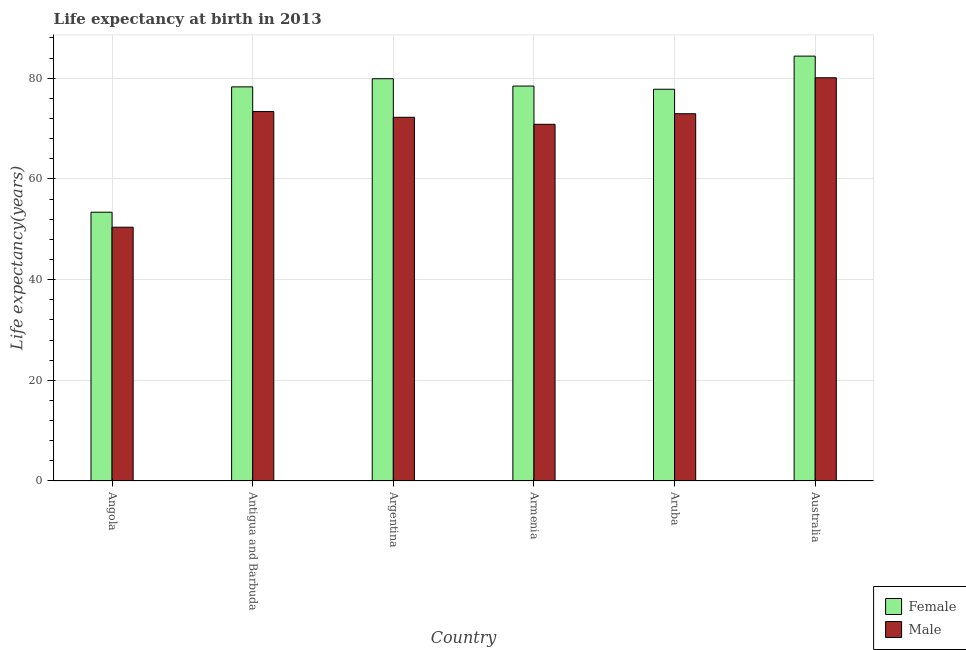How many groups of bars are there?
Offer a terse response. 6. Are the number of bars per tick equal to the number of legend labels?
Offer a terse response. Yes. How many bars are there on the 6th tick from the left?
Provide a succinct answer. 2. What is the label of the 4th group of bars from the left?
Your response must be concise. Armenia. In how many cases, is the number of bars for a given country not equal to the number of legend labels?
Provide a succinct answer. 0. What is the life expectancy(female) in Aruba?
Offer a terse response. 77.82. Across all countries, what is the maximum life expectancy(male)?
Your answer should be very brief. 80.1. Across all countries, what is the minimum life expectancy(male)?
Offer a very short reply. 50.41. In which country was the life expectancy(female) maximum?
Your answer should be very brief. Australia. In which country was the life expectancy(female) minimum?
Your answer should be compact. Angola. What is the total life expectancy(female) in the graph?
Your answer should be compact. 452.27. What is the difference between the life expectancy(male) in Antigua and Barbuda and that in Armenia?
Your answer should be very brief. 2.53. What is the difference between the life expectancy(male) in Australia and the life expectancy(female) in Antigua and Barbuda?
Your answer should be compact. 1.81. What is the average life expectancy(male) per country?
Provide a succinct answer. 69.99. What is the difference between the life expectancy(male) and life expectancy(female) in Aruba?
Give a very brief answer. -4.87. What is the ratio of the life expectancy(female) in Antigua and Barbuda to that in Argentina?
Provide a short and direct response. 0.98. Is the life expectancy(female) in Angola less than that in Australia?
Ensure brevity in your answer.  Yes. Is the difference between the life expectancy(male) in Antigua and Barbuda and Argentina greater than the difference between the life expectancy(female) in Antigua and Barbuda and Argentina?
Keep it short and to the point. Yes. What is the difference between the highest and the second highest life expectancy(male)?
Your answer should be very brief. 6.71. What is the difference between the highest and the lowest life expectancy(female)?
Provide a short and direct response. 31.01. In how many countries, is the life expectancy(female) greater than the average life expectancy(female) taken over all countries?
Ensure brevity in your answer.  5. What is the difference between two consecutive major ticks on the Y-axis?
Keep it short and to the point. 20. Does the graph contain grids?
Provide a short and direct response. Yes. How are the legend labels stacked?
Offer a very short reply. Vertical. What is the title of the graph?
Make the answer very short. Life expectancy at birth in 2013. Does "Official aid received" appear as one of the legend labels in the graph?
Make the answer very short. No. What is the label or title of the Y-axis?
Offer a very short reply. Life expectancy(years). What is the Life expectancy(years) in Female in Angola?
Give a very brief answer. 53.39. What is the Life expectancy(years) in Male in Angola?
Your answer should be compact. 50.41. What is the Life expectancy(years) of Female in Antigua and Barbuda?
Give a very brief answer. 78.29. What is the Life expectancy(years) in Male in Antigua and Barbuda?
Offer a very short reply. 73.39. What is the Life expectancy(years) in Female in Argentina?
Keep it short and to the point. 79.91. What is the Life expectancy(years) in Male in Argentina?
Offer a very short reply. 72.25. What is the Life expectancy(years) in Female in Armenia?
Your answer should be compact. 78.45. What is the Life expectancy(years) in Male in Armenia?
Provide a short and direct response. 70.86. What is the Life expectancy(years) in Female in Aruba?
Your answer should be very brief. 77.82. What is the Life expectancy(years) of Male in Aruba?
Your response must be concise. 72.95. What is the Life expectancy(years) of Female in Australia?
Offer a terse response. 84.4. What is the Life expectancy(years) of Male in Australia?
Your answer should be very brief. 80.1. Across all countries, what is the maximum Life expectancy(years) of Female?
Your answer should be compact. 84.4. Across all countries, what is the maximum Life expectancy(years) in Male?
Offer a very short reply. 80.1. Across all countries, what is the minimum Life expectancy(years) of Female?
Provide a short and direct response. 53.39. Across all countries, what is the minimum Life expectancy(years) in Male?
Your answer should be very brief. 50.41. What is the total Life expectancy(years) of Female in the graph?
Your answer should be very brief. 452.27. What is the total Life expectancy(years) of Male in the graph?
Ensure brevity in your answer.  419.96. What is the difference between the Life expectancy(years) in Female in Angola and that in Antigua and Barbuda?
Provide a short and direct response. -24.9. What is the difference between the Life expectancy(years) of Male in Angola and that in Antigua and Barbuda?
Your answer should be very brief. -22.97. What is the difference between the Life expectancy(years) of Female in Angola and that in Argentina?
Offer a very short reply. -26.52. What is the difference between the Life expectancy(years) of Male in Angola and that in Argentina?
Provide a succinct answer. -21.84. What is the difference between the Life expectancy(years) in Female in Angola and that in Armenia?
Your response must be concise. -25.06. What is the difference between the Life expectancy(years) of Male in Angola and that in Armenia?
Provide a short and direct response. -20.44. What is the difference between the Life expectancy(years) in Female in Angola and that in Aruba?
Ensure brevity in your answer.  -24.43. What is the difference between the Life expectancy(years) in Male in Angola and that in Aruba?
Offer a terse response. -22.54. What is the difference between the Life expectancy(years) in Female in Angola and that in Australia?
Make the answer very short. -31.01. What is the difference between the Life expectancy(years) in Male in Angola and that in Australia?
Give a very brief answer. -29.69. What is the difference between the Life expectancy(years) of Female in Antigua and Barbuda and that in Argentina?
Your answer should be very brief. -1.62. What is the difference between the Life expectancy(years) in Male in Antigua and Barbuda and that in Argentina?
Provide a succinct answer. 1.14. What is the difference between the Life expectancy(years) of Female in Antigua and Barbuda and that in Armenia?
Your answer should be very brief. -0.16. What is the difference between the Life expectancy(years) in Male in Antigua and Barbuda and that in Armenia?
Make the answer very short. 2.53. What is the difference between the Life expectancy(years) in Female in Antigua and Barbuda and that in Aruba?
Your response must be concise. 0.47. What is the difference between the Life expectancy(years) in Male in Antigua and Barbuda and that in Aruba?
Offer a very short reply. 0.43. What is the difference between the Life expectancy(years) in Female in Antigua and Barbuda and that in Australia?
Make the answer very short. -6.11. What is the difference between the Life expectancy(years) of Male in Antigua and Barbuda and that in Australia?
Make the answer very short. -6.71. What is the difference between the Life expectancy(years) of Female in Argentina and that in Armenia?
Make the answer very short. 1.46. What is the difference between the Life expectancy(years) of Male in Argentina and that in Armenia?
Your answer should be very brief. 1.39. What is the difference between the Life expectancy(years) of Female in Argentina and that in Aruba?
Ensure brevity in your answer.  2.09. What is the difference between the Life expectancy(years) of Male in Argentina and that in Aruba?
Provide a succinct answer. -0.7. What is the difference between the Life expectancy(years) of Female in Argentina and that in Australia?
Offer a very short reply. -4.49. What is the difference between the Life expectancy(years) of Male in Argentina and that in Australia?
Keep it short and to the point. -7.85. What is the difference between the Life expectancy(years) in Female in Armenia and that in Aruba?
Keep it short and to the point. 0.63. What is the difference between the Life expectancy(years) in Male in Armenia and that in Aruba?
Provide a short and direct response. -2.1. What is the difference between the Life expectancy(years) of Female in Armenia and that in Australia?
Ensure brevity in your answer.  -5.95. What is the difference between the Life expectancy(years) in Male in Armenia and that in Australia?
Give a very brief answer. -9.24. What is the difference between the Life expectancy(years) in Female in Aruba and that in Australia?
Your answer should be compact. -6.58. What is the difference between the Life expectancy(years) in Male in Aruba and that in Australia?
Keep it short and to the point. -7.14. What is the difference between the Life expectancy(years) in Female in Angola and the Life expectancy(years) in Male in Antigua and Barbuda?
Your response must be concise. -19.99. What is the difference between the Life expectancy(years) in Female in Angola and the Life expectancy(years) in Male in Argentina?
Provide a short and direct response. -18.86. What is the difference between the Life expectancy(years) in Female in Angola and the Life expectancy(years) in Male in Armenia?
Offer a terse response. -17.46. What is the difference between the Life expectancy(years) in Female in Angola and the Life expectancy(years) in Male in Aruba?
Ensure brevity in your answer.  -19.56. What is the difference between the Life expectancy(years) in Female in Angola and the Life expectancy(years) in Male in Australia?
Provide a succinct answer. -26.71. What is the difference between the Life expectancy(years) of Female in Antigua and Barbuda and the Life expectancy(years) of Male in Argentina?
Make the answer very short. 6.04. What is the difference between the Life expectancy(years) of Female in Antigua and Barbuda and the Life expectancy(years) of Male in Armenia?
Your response must be concise. 7.44. What is the difference between the Life expectancy(years) in Female in Antigua and Barbuda and the Life expectancy(years) in Male in Aruba?
Offer a terse response. 5.34. What is the difference between the Life expectancy(years) in Female in Antigua and Barbuda and the Life expectancy(years) in Male in Australia?
Your response must be concise. -1.81. What is the difference between the Life expectancy(years) in Female in Argentina and the Life expectancy(years) in Male in Armenia?
Give a very brief answer. 9.05. What is the difference between the Life expectancy(years) in Female in Argentina and the Life expectancy(years) in Male in Aruba?
Keep it short and to the point. 6.95. What is the difference between the Life expectancy(years) of Female in Argentina and the Life expectancy(years) of Male in Australia?
Provide a succinct answer. -0.19. What is the difference between the Life expectancy(years) of Female in Armenia and the Life expectancy(years) of Male in Aruba?
Offer a very short reply. 5.5. What is the difference between the Life expectancy(years) of Female in Armenia and the Life expectancy(years) of Male in Australia?
Offer a terse response. -1.65. What is the difference between the Life expectancy(years) in Female in Aruba and the Life expectancy(years) in Male in Australia?
Offer a terse response. -2.28. What is the average Life expectancy(years) in Female per country?
Your response must be concise. 75.38. What is the average Life expectancy(years) in Male per country?
Your answer should be compact. 69.99. What is the difference between the Life expectancy(years) of Female and Life expectancy(years) of Male in Angola?
Ensure brevity in your answer.  2.98. What is the difference between the Life expectancy(years) in Female and Life expectancy(years) in Male in Antigua and Barbuda?
Make the answer very short. 4.91. What is the difference between the Life expectancy(years) in Female and Life expectancy(years) in Male in Argentina?
Provide a succinct answer. 7.66. What is the difference between the Life expectancy(years) in Female and Life expectancy(years) in Male in Armenia?
Give a very brief answer. 7.6. What is the difference between the Life expectancy(years) of Female and Life expectancy(years) of Male in Aruba?
Your response must be concise. 4.87. What is the difference between the Life expectancy(years) of Female and Life expectancy(years) of Male in Australia?
Keep it short and to the point. 4.3. What is the ratio of the Life expectancy(years) in Female in Angola to that in Antigua and Barbuda?
Make the answer very short. 0.68. What is the ratio of the Life expectancy(years) in Male in Angola to that in Antigua and Barbuda?
Keep it short and to the point. 0.69. What is the ratio of the Life expectancy(years) in Female in Angola to that in Argentina?
Keep it short and to the point. 0.67. What is the ratio of the Life expectancy(years) in Male in Angola to that in Argentina?
Provide a short and direct response. 0.7. What is the ratio of the Life expectancy(years) of Female in Angola to that in Armenia?
Your answer should be compact. 0.68. What is the ratio of the Life expectancy(years) of Male in Angola to that in Armenia?
Give a very brief answer. 0.71. What is the ratio of the Life expectancy(years) of Female in Angola to that in Aruba?
Give a very brief answer. 0.69. What is the ratio of the Life expectancy(years) of Male in Angola to that in Aruba?
Your answer should be very brief. 0.69. What is the ratio of the Life expectancy(years) in Female in Angola to that in Australia?
Your response must be concise. 0.63. What is the ratio of the Life expectancy(years) of Male in Angola to that in Australia?
Keep it short and to the point. 0.63. What is the ratio of the Life expectancy(years) of Female in Antigua and Barbuda to that in Argentina?
Provide a succinct answer. 0.98. What is the ratio of the Life expectancy(years) in Male in Antigua and Barbuda to that in Argentina?
Your answer should be very brief. 1.02. What is the ratio of the Life expectancy(years) of Male in Antigua and Barbuda to that in Armenia?
Give a very brief answer. 1.04. What is the ratio of the Life expectancy(years) in Male in Antigua and Barbuda to that in Aruba?
Your answer should be compact. 1.01. What is the ratio of the Life expectancy(years) in Female in Antigua and Barbuda to that in Australia?
Your answer should be compact. 0.93. What is the ratio of the Life expectancy(years) in Male in Antigua and Barbuda to that in Australia?
Offer a terse response. 0.92. What is the ratio of the Life expectancy(years) in Female in Argentina to that in Armenia?
Keep it short and to the point. 1.02. What is the ratio of the Life expectancy(years) in Male in Argentina to that in Armenia?
Offer a terse response. 1.02. What is the ratio of the Life expectancy(years) in Female in Argentina to that in Aruba?
Provide a succinct answer. 1.03. What is the ratio of the Life expectancy(years) in Male in Argentina to that in Aruba?
Give a very brief answer. 0.99. What is the ratio of the Life expectancy(years) of Female in Argentina to that in Australia?
Make the answer very short. 0.95. What is the ratio of the Life expectancy(years) of Male in Argentina to that in Australia?
Offer a terse response. 0.9. What is the ratio of the Life expectancy(years) of Male in Armenia to that in Aruba?
Your response must be concise. 0.97. What is the ratio of the Life expectancy(years) of Female in Armenia to that in Australia?
Give a very brief answer. 0.93. What is the ratio of the Life expectancy(years) in Male in Armenia to that in Australia?
Your answer should be very brief. 0.88. What is the ratio of the Life expectancy(years) in Female in Aruba to that in Australia?
Ensure brevity in your answer.  0.92. What is the ratio of the Life expectancy(years) in Male in Aruba to that in Australia?
Offer a very short reply. 0.91. What is the difference between the highest and the second highest Life expectancy(years) of Female?
Ensure brevity in your answer.  4.49. What is the difference between the highest and the second highest Life expectancy(years) in Male?
Your answer should be very brief. 6.71. What is the difference between the highest and the lowest Life expectancy(years) of Female?
Provide a short and direct response. 31.01. What is the difference between the highest and the lowest Life expectancy(years) of Male?
Provide a succinct answer. 29.69. 